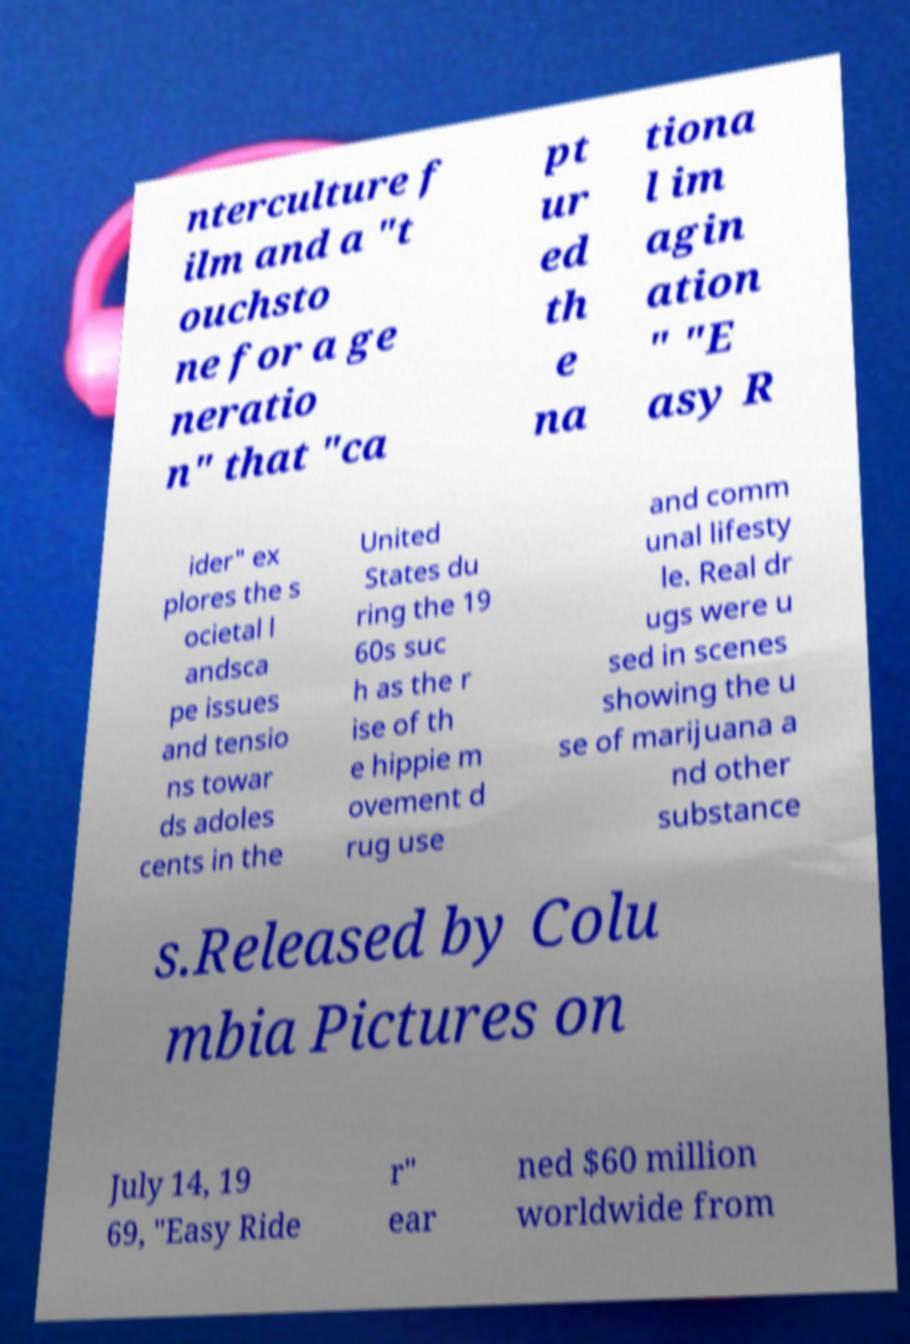Please identify and transcribe the text found in this image. nterculture f ilm and a "t ouchsto ne for a ge neratio n" that "ca pt ur ed th e na tiona l im agin ation " "E asy R ider" ex plores the s ocietal l andsca pe issues and tensio ns towar ds adoles cents in the United States du ring the 19 60s suc h as the r ise of th e hippie m ovement d rug use and comm unal lifesty le. Real dr ugs were u sed in scenes showing the u se of marijuana a nd other substance s.Released by Colu mbia Pictures on July 14, 19 69, "Easy Ride r" ear ned $60 million worldwide from 